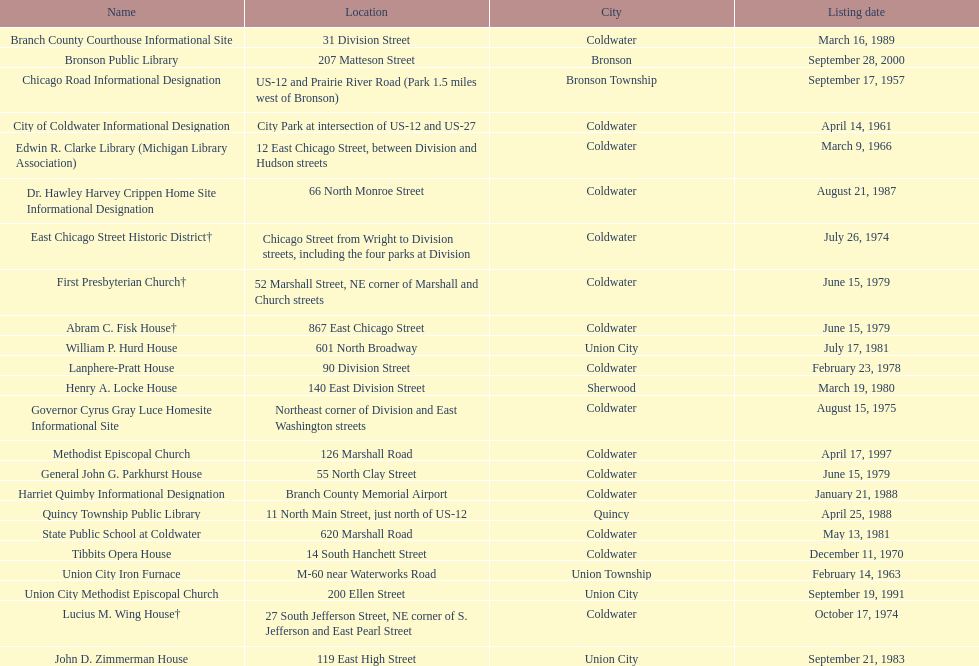Between the historical records of public libraries in quincy and bronson, how many years have elapsed? 12. 